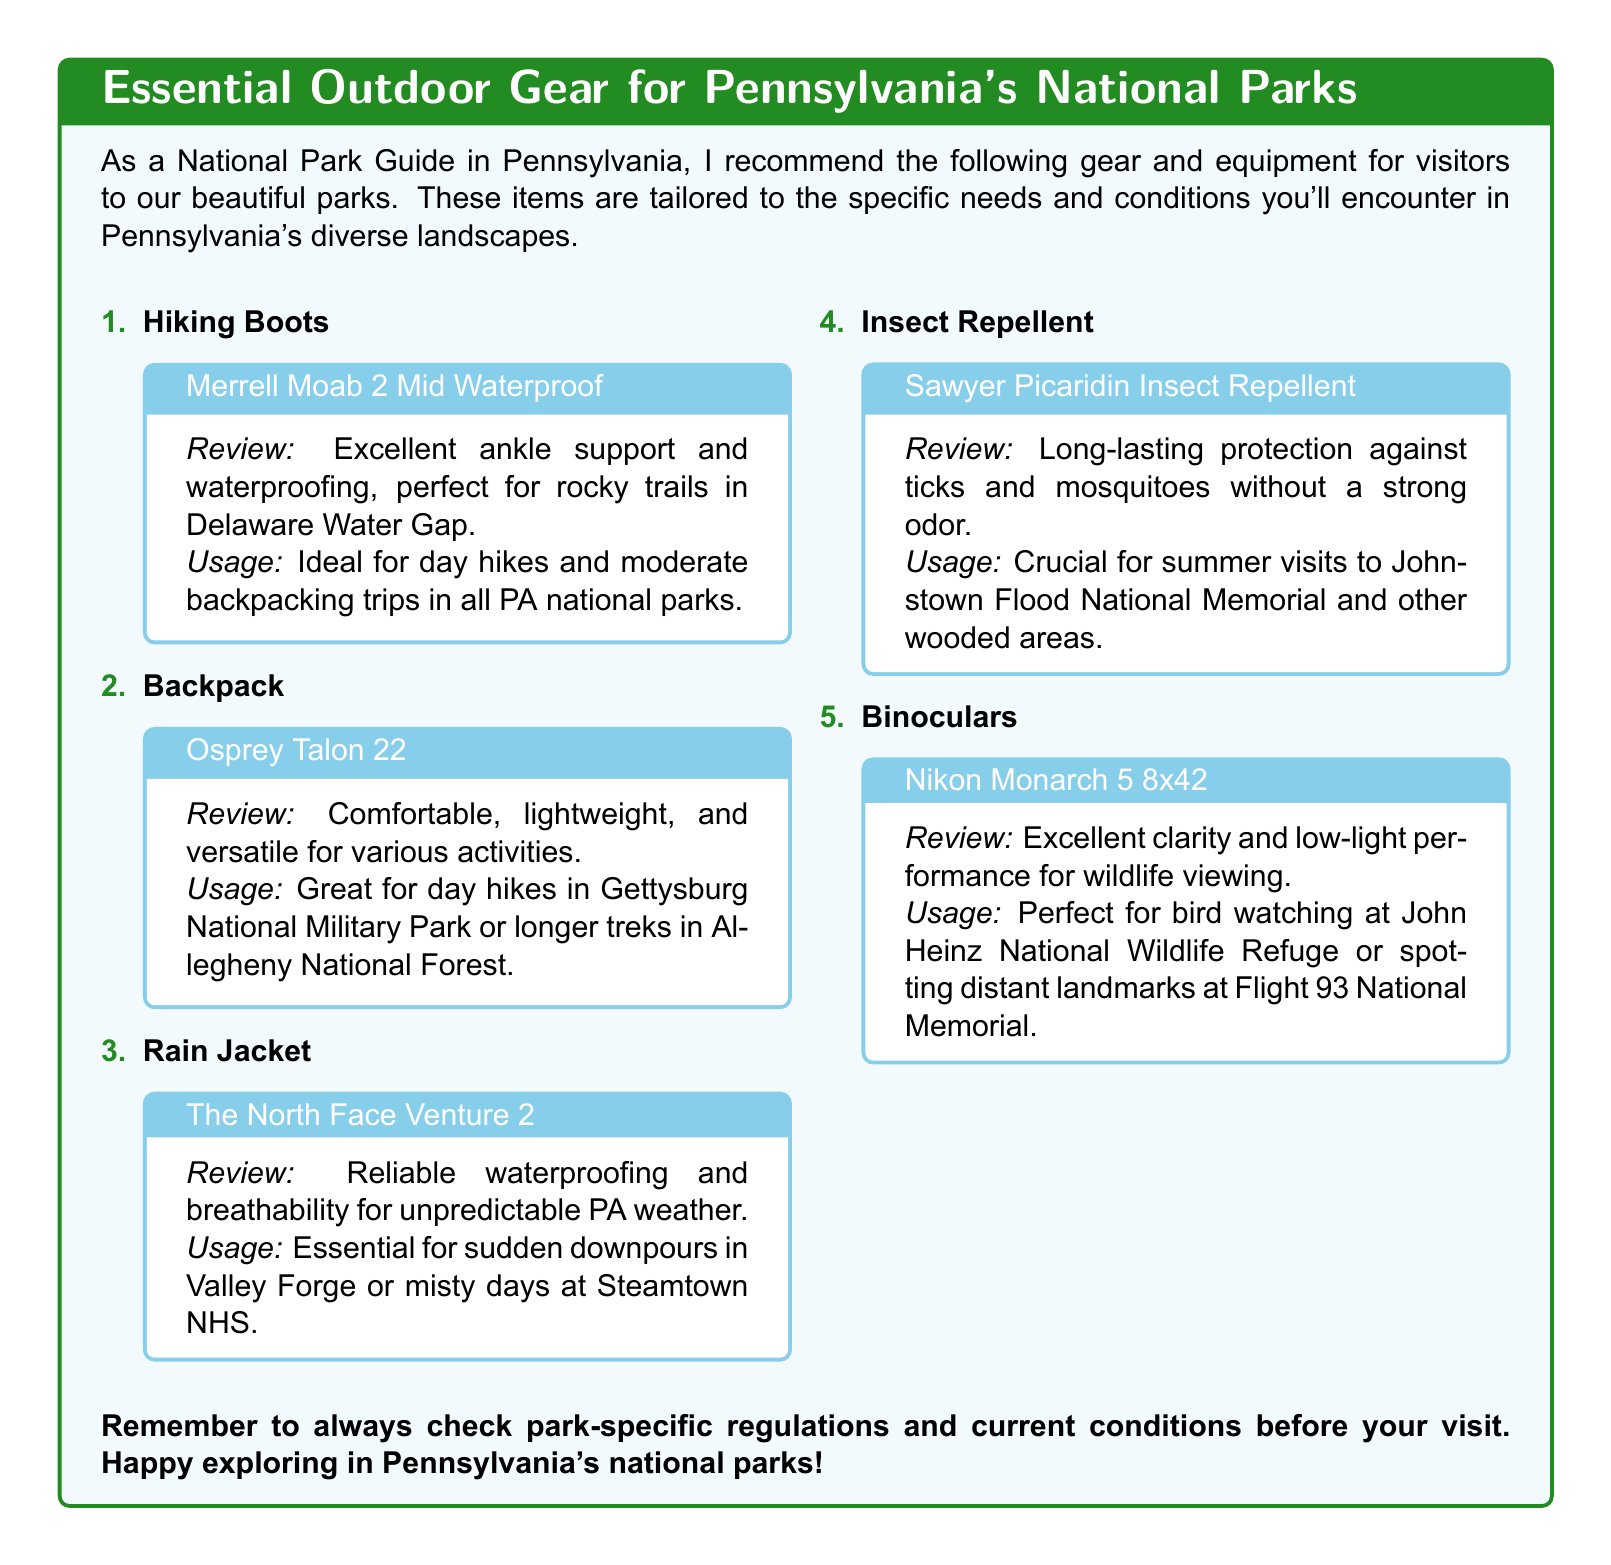What hiking boots are recommended? The recommendation for hiking boots is for the Merrell Moab 2 Mid Waterproof.
Answer: Merrell Moab 2 Mid Waterproof What is the main feature of the Osprey Talon 22? The main feature highlighted for the Osprey Talon 22 is its comfort and versatility for various activities.
Answer: Comfortable, lightweight, and versatile Which rain jacket is suggested for Pennsylvania's unpredictable weather? The suggested rain jacket for unpredictable Pennsylvania weather is The North Face Venture 2.
Answer: The North Face Venture 2 What type of insect repellent is recommended? The insect repellent recommended is Sawyer Picaridin Insect Repellent.
Answer: Sawyer Picaridin Insect Repellent For which park is the Nikon Monarch 5 binoculars particularly useful? The Nikon Monarch 5 binoculars are particularly useful for bird watching at John Heinz National Wildlife Refuge.
Answer: John Heinz National Wildlife Refuge Why is insect repellent crucial? Insect repellent is crucial for summer visits to areas like Johnstown Flood National Memorial.
Answer: Summer visits to Johnstown Flood National Memorial What type of document is this? This document is a catalog recommending outdoor gear and equipment for visitors to Pennsylvania’s national parks.
Answer: Catalog How many items are listed in the gear recommendations? There are five items listed in the gear recommendations.
Answer: Five Which color represents the title background? The title background is represented in skyblue.
Answer: Skyblue 